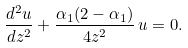<formula> <loc_0><loc_0><loc_500><loc_500>\frac { d ^ { 2 } u } { d z ^ { 2 } } + \frac { \alpha _ { 1 } ( 2 - \alpha _ { 1 } ) } { 4 z ^ { 2 } } \, u = 0 .</formula> 